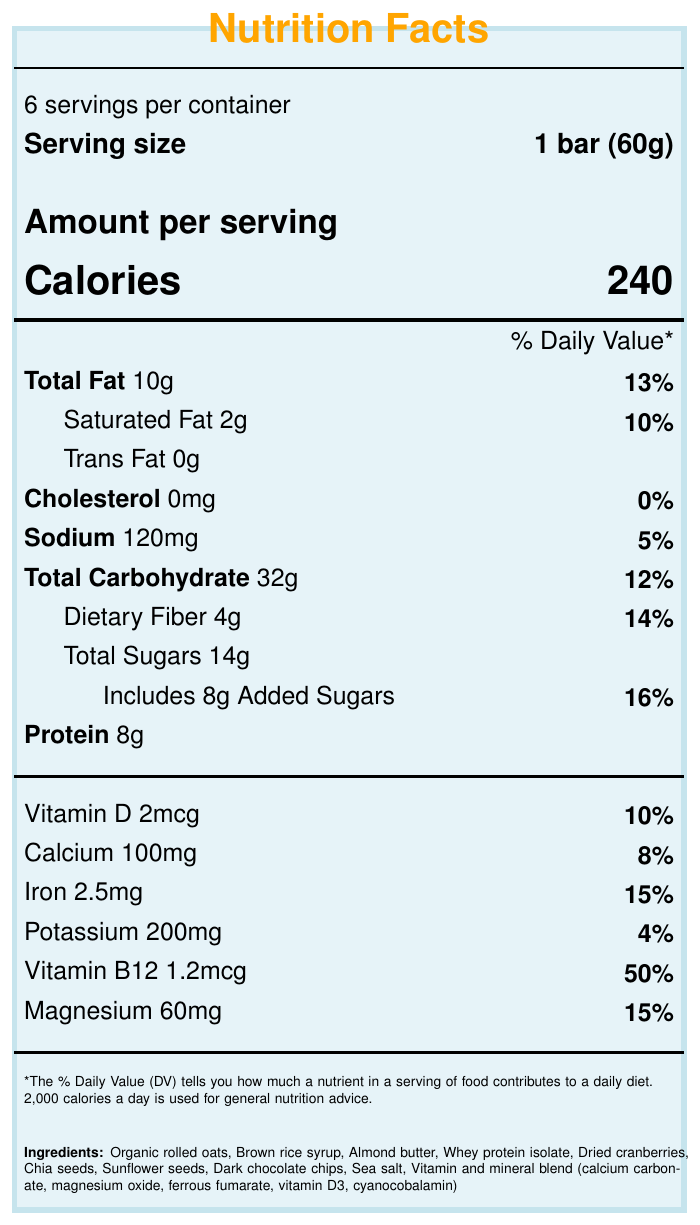What is the serving size of the SnowPro Energy Bar? The serving size information is specified as "1 bar (60g)" in the serving information section of the document.
Answer: 1 bar (60g) How many calories are in one serving of the SnowPro Energy Bar? The document mentions that there are 240 calories per serving.
Answer: 240 What percentage of the daily value of vitamin B12 does one serving of the SnowPro Energy Bar provide? The nutrition information indicates that one serving provides 50% of the daily value of vitamin B12.
Answer: 50% What allergens are present in the SnowPro Energy Bar? The allergen information section states that the product contains milk and tree nuts (almonds) and may contain traces of peanuts and soy.
Answer: Milk and tree nuts (almonds). May contain traces of peanuts and soy. How much dietary fiber is in one serving of the SnowPro Energy Bar? The document shows that one serving of the bar contains 4g of dietary fiber.
Answer: 4g Which ingredient is not listed in the SnowPro Energy Bar? A. Organic rolled oats B. Almond butter C. Peanut butter D. Dark chocolate chips The ingredients list includes organic rolled oats, almond butter, and dark chocolate chips, but not peanut butter.
Answer: C. Peanut butter How much protein does one serving of the SnowPro Energy Bar contain? The protein content per serving is listed as 8g in the nutrition information section.
Answer: 8g True or False: The SnowPro Energy Bar contains artificial flavors and preservatives. One of the claim statements clearly states that the bar contains no artificial flavors or preservatives.
Answer: False Which of the following best describes the main purpose of this document? A. To provide a recipe for a homemade energy bar B. To give detailed nutritional information about the SnowPro Energy Bar C. To advertise the SnowPro brand D. To discuss different types of snacks for athletes The document primarily provides nutritional facts and ingredient information about the SnowPro Energy Bar.
Answer: B. To give detailed nutritional information about the SnowPro Energy Bar What is the total fat content in one serving of the SnowPro Energy Bar? The total fat content is listed as 10g per serving.
Answer: 10g Summarize the main points covered in this document. The document covers various aspects of the SnowPro Energy Bar such as nutritional values for different nutrients, ingredients used, potential allergens, health claims, and usage instructions.
Answer: The document provides detailed nutritional information about the SnowPro Energy Bar, including serving size, calories, fat, carbohydrates, protein, vitamins, and minerals per serving. It also lists the ingredients, allergen information, claim statements, and storage instructions. What are the storage instructions for the SnowPro Energy Bar? The storage instructions are specified at the end of the document.
Answer: Store in a cool, dry place. For best taste, consume within 6 months of production date. What is the address of the manufacturer of the SnowPro Energy Bar? The document lists the manufacturer's address at the end.
Answer: 123 Powder Lane, Breckenridge, CO 80424 Which ingredient in the SnowPro Energy Bar provides protein? A. Brown rice syrup B. Whey protein isolate C. Dried cranberries D. Organic rolled oats The ingredients list includes whey protein isolate, which is a direct source of protein.
Answer: B. Whey protein isolate Can the exact production date of the SnowPro Energy Bar be determined from this document? The document does not provide the exact production date of the energy bar, just storage instructions post-production date.
Answer: Not enough information What is the sodium content in one serving of the SnowPro Energy Bar? The sodium content is listed as 120mg per serving in the nutrition information section.
Answer: 120mg 